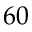Convert formula to latex. <formula><loc_0><loc_0><loc_500><loc_500>6 0</formula> 